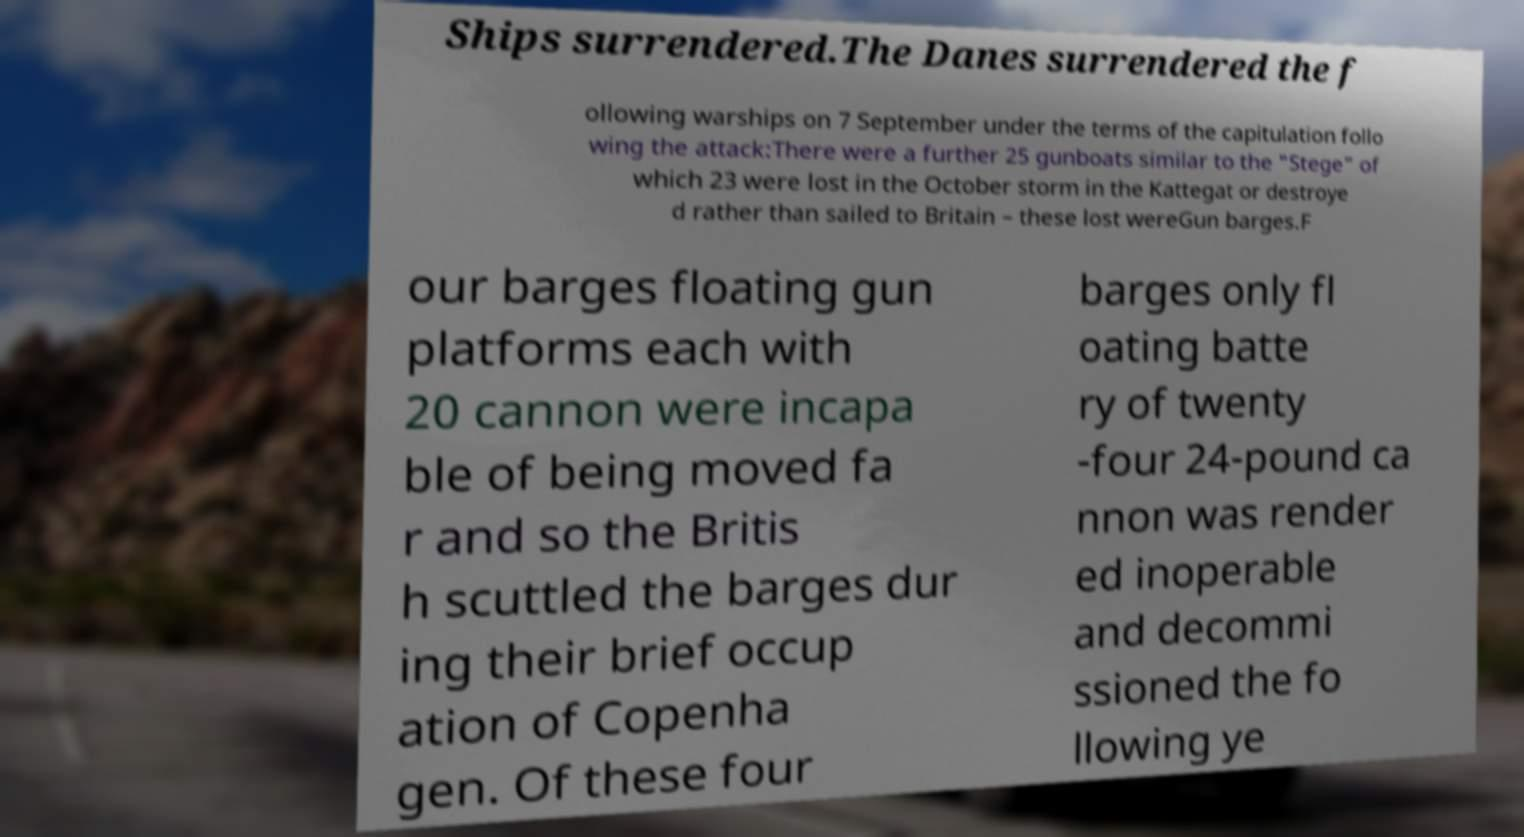There's text embedded in this image that I need extracted. Can you transcribe it verbatim? Ships surrendered.The Danes surrendered the f ollowing warships on 7 September under the terms of the capitulation follo wing the attack:There were a further 25 gunboats similar to the "Stege" of which 23 were lost in the October storm in the Kattegat or destroye d rather than sailed to Britain – these lost wereGun barges.F our barges floating gun platforms each with 20 cannon were incapa ble of being moved fa r and so the Britis h scuttled the barges dur ing their brief occup ation of Copenha gen. Of these four barges only fl oating batte ry of twenty -four 24-pound ca nnon was render ed inoperable and decommi ssioned the fo llowing ye 